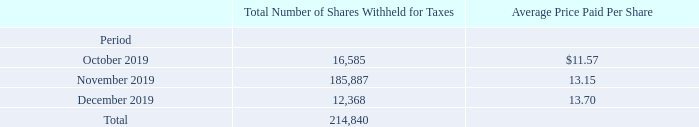Issuer Purchases of Equity Securities
The following table contains information about shares of our previously-issued common stock that we withheld from employees upon vesting of their stock-based awards during the fourth quarter of 2019 to satisfy the related tax withholding obligations:
What information does the table contain? Information about shares of our previously-issued common stock that we withheld from employees upon vesting of their stock-based awards during the fourth quarter of 2019 to satisfy the related tax withholding obligations. What is the average price paid per share in October 2019? $11.57. Which periods does the table contain? October 2019, november 2019, december 2019. Which period has the largest average price paid per share? $13.70>$13.15>$11.57
Answer: december 2019. What is the average number of shares withheld for taxes per month? 214,840/3
Answer: 71613.33. What is the percentage change in the average price paid per share between December 2019 and November 2019?
Answer scale should be: percent. (13.70-13.15)/13.15
Answer: 4.18. 